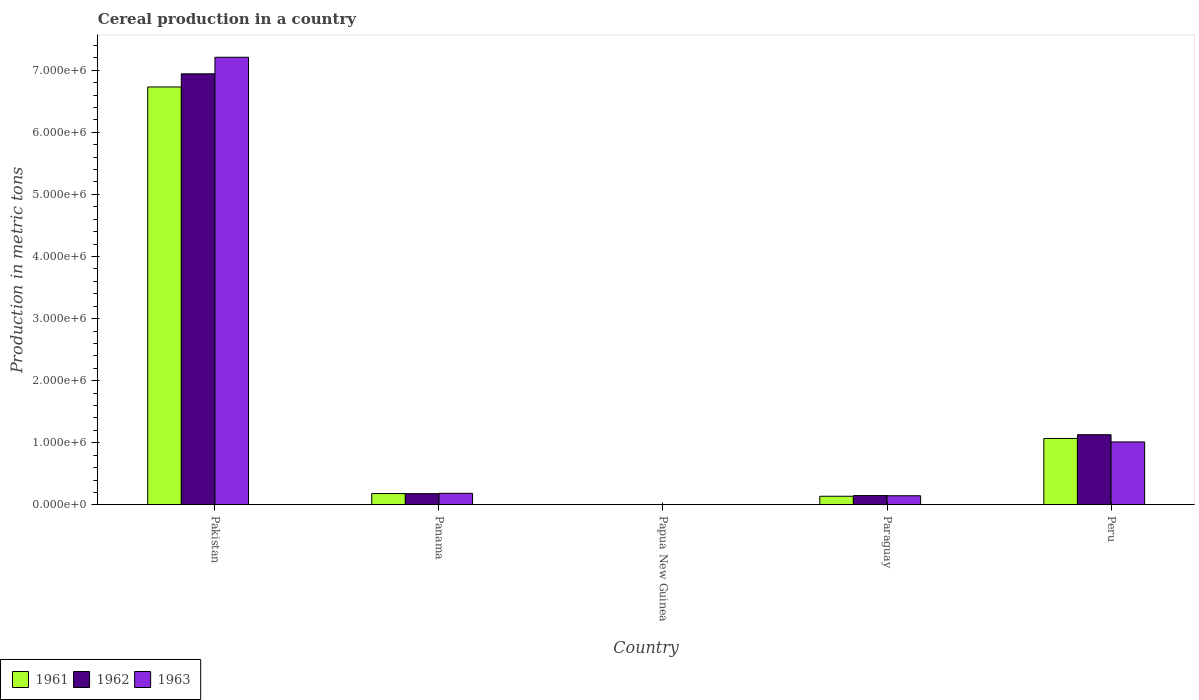How many different coloured bars are there?
Provide a short and direct response. 3. Are the number of bars on each tick of the X-axis equal?
Your answer should be compact. Yes. How many bars are there on the 5th tick from the right?
Give a very brief answer. 3. What is the total cereal production in 1962 in Papua New Guinea?
Ensure brevity in your answer.  1891. Across all countries, what is the maximum total cereal production in 1962?
Give a very brief answer. 6.94e+06. Across all countries, what is the minimum total cereal production in 1963?
Provide a short and direct response. 1871. In which country was the total cereal production in 1962 maximum?
Your answer should be compact. Pakistan. In which country was the total cereal production in 1961 minimum?
Keep it short and to the point. Papua New Guinea. What is the total total cereal production in 1962 in the graph?
Your response must be concise. 8.41e+06. What is the difference between the total cereal production in 1962 in Papua New Guinea and that in Paraguay?
Give a very brief answer. -1.49e+05. What is the difference between the total cereal production in 1961 in Pakistan and the total cereal production in 1962 in Panama?
Provide a short and direct response. 6.55e+06. What is the average total cereal production in 1961 per country?
Your answer should be compact. 1.62e+06. What is the difference between the total cereal production of/in 1962 and total cereal production of/in 1961 in Papua New Guinea?
Your response must be concise. 41. What is the ratio of the total cereal production in 1963 in Panama to that in Papua New Guinea?
Make the answer very short. 99.94. Is the total cereal production in 1962 in Papua New Guinea less than that in Peru?
Your response must be concise. Yes. What is the difference between the highest and the second highest total cereal production in 1961?
Provide a short and direct response. 6.55e+06. What is the difference between the highest and the lowest total cereal production in 1961?
Give a very brief answer. 6.73e+06. In how many countries, is the total cereal production in 1962 greater than the average total cereal production in 1962 taken over all countries?
Your answer should be very brief. 1. How many bars are there?
Keep it short and to the point. 15. What is the difference between two consecutive major ticks on the Y-axis?
Your response must be concise. 1.00e+06. Are the values on the major ticks of Y-axis written in scientific E-notation?
Your answer should be compact. Yes. Does the graph contain any zero values?
Offer a very short reply. No. How many legend labels are there?
Ensure brevity in your answer.  3. How are the legend labels stacked?
Provide a short and direct response. Horizontal. What is the title of the graph?
Make the answer very short. Cereal production in a country. Does "1986" appear as one of the legend labels in the graph?
Provide a short and direct response. No. What is the label or title of the X-axis?
Offer a terse response. Country. What is the label or title of the Y-axis?
Give a very brief answer. Production in metric tons. What is the Production in metric tons of 1961 in Pakistan?
Your response must be concise. 6.73e+06. What is the Production in metric tons of 1962 in Pakistan?
Give a very brief answer. 6.94e+06. What is the Production in metric tons in 1963 in Pakistan?
Offer a very short reply. 7.21e+06. What is the Production in metric tons of 1961 in Panama?
Offer a terse response. 1.83e+05. What is the Production in metric tons in 1962 in Panama?
Give a very brief answer. 1.82e+05. What is the Production in metric tons of 1963 in Panama?
Offer a very short reply. 1.87e+05. What is the Production in metric tons of 1961 in Papua New Guinea?
Your answer should be compact. 1850. What is the Production in metric tons in 1962 in Papua New Guinea?
Ensure brevity in your answer.  1891. What is the Production in metric tons in 1963 in Papua New Guinea?
Make the answer very short. 1871. What is the Production in metric tons of 1961 in Paraguay?
Offer a very short reply. 1.40e+05. What is the Production in metric tons of 1962 in Paraguay?
Your response must be concise. 1.51e+05. What is the Production in metric tons in 1963 in Paraguay?
Ensure brevity in your answer.  1.48e+05. What is the Production in metric tons in 1961 in Peru?
Provide a succinct answer. 1.07e+06. What is the Production in metric tons in 1962 in Peru?
Your answer should be compact. 1.13e+06. What is the Production in metric tons of 1963 in Peru?
Offer a very short reply. 1.01e+06. Across all countries, what is the maximum Production in metric tons of 1961?
Keep it short and to the point. 6.73e+06. Across all countries, what is the maximum Production in metric tons in 1962?
Provide a succinct answer. 6.94e+06. Across all countries, what is the maximum Production in metric tons in 1963?
Your response must be concise. 7.21e+06. Across all countries, what is the minimum Production in metric tons in 1961?
Give a very brief answer. 1850. Across all countries, what is the minimum Production in metric tons in 1962?
Your answer should be very brief. 1891. Across all countries, what is the minimum Production in metric tons of 1963?
Offer a very short reply. 1871. What is the total Production in metric tons of 1961 in the graph?
Make the answer very short. 8.12e+06. What is the total Production in metric tons of 1962 in the graph?
Your response must be concise. 8.41e+06. What is the total Production in metric tons of 1963 in the graph?
Your answer should be compact. 8.56e+06. What is the difference between the Production in metric tons in 1961 in Pakistan and that in Panama?
Make the answer very short. 6.55e+06. What is the difference between the Production in metric tons in 1962 in Pakistan and that in Panama?
Your response must be concise. 6.76e+06. What is the difference between the Production in metric tons of 1963 in Pakistan and that in Panama?
Your response must be concise. 7.02e+06. What is the difference between the Production in metric tons in 1961 in Pakistan and that in Papua New Guinea?
Your answer should be very brief. 6.73e+06. What is the difference between the Production in metric tons of 1962 in Pakistan and that in Papua New Guinea?
Offer a very short reply. 6.94e+06. What is the difference between the Production in metric tons of 1963 in Pakistan and that in Papua New Guinea?
Your response must be concise. 7.21e+06. What is the difference between the Production in metric tons in 1961 in Pakistan and that in Paraguay?
Provide a succinct answer. 6.59e+06. What is the difference between the Production in metric tons in 1962 in Pakistan and that in Paraguay?
Your answer should be compact. 6.79e+06. What is the difference between the Production in metric tons in 1963 in Pakistan and that in Paraguay?
Your answer should be very brief. 7.06e+06. What is the difference between the Production in metric tons in 1961 in Pakistan and that in Peru?
Your answer should be very brief. 5.66e+06. What is the difference between the Production in metric tons of 1962 in Pakistan and that in Peru?
Provide a short and direct response. 5.81e+06. What is the difference between the Production in metric tons of 1963 in Pakistan and that in Peru?
Your answer should be compact. 6.19e+06. What is the difference between the Production in metric tons of 1961 in Panama and that in Papua New Guinea?
Provide a succinct answer. 1.81e+05. What is the difference between the Production in metric tons of 1962 in Panama and that in Papua New Guinea?
Your answer should be compact. 1.80e+05. What is the difference between the Production in metric tons in 1963 in Panama and that in Papua New Guinea?
Make the answer very short. 1.85e+05. What is the difference between the Production in metric tons in 1961 in Panama and that in Paraguay?
Keep it short and to the point. 4.32e+04. What is the difference between the Production in metric tons in 1962 in Panama and that in Paraguay?
Make the answer very short. 3.08e+04. What is the difference between the Production in metric tons of 1963 in Panama and that in Paraguay?
Offer a terse response. 3.92e+04. What is the difference between the Production in metric tons in 1961 in Panama and that in Peru?
Your response must be concise. -8.87e+05. What is the difference between the Production in metric tons in 1962 in Panama and that in Peru?
Provide a succinct answer. -9.49e+05. What is the difference between the Production in metric tons in 1963 in Panama and that in Peru?
Make the answer very short. -8.27e+05. What is the difference between the Production in metric tons of 1961 in Papua New Guinea and that in Paraguay?
Make the answer very short. -1.38e+05. What is the difference between the Production in metric tons of 1962 in Papua New Guinea and that in Paraguay?
Offer a very short reply. -1.49e+05. What is the difference between the Production in metric tons of 1963 in Papua New Guinea and that in Paraguay?
Your answer should be very brief. -1.46e+05. What is the difference between the Production in metric tons in 1961 in Papua New Guinea and that in Peru?
Make the answer very short. -1.07e+06. What is the difference between the Production in metric tons of 1962 in Papua New Guinea and that in Peru?
Give a very brief answer. -1.13e+06. What is the difference between the Production in metric tons in 1963 in Papua New Guinea and that in Peru?
Ensure brevity in your answer.  -1.01e+06. What is the difference between the Production in metric tons of 1961 in Paraguay and that in Peru?
Give a very brief answer. -9.30e+05. What is the difference between the Production in metric tons of 1962 in Paraguay and that in Peru?
Your answer should be compact. -9.80e+05. What is the difference between the Production in metric tons of 1963 in Paraguay and that in Peru?
Offer a very short reply. -8.67e+05. What is the difference between the Production in metric tons in 1961 in Pakistan and the Production in metric tons in 1962 in Panama?
Your answer should be compact. 6.55e+06. What is the difference between the Production in metric tons of 1961 in Pakistan and the Production in metric tons of 1963 in Panama?
Provide a succinct answer. 6.54e+06. What is the difference between the Production in metric tons of 1962 in Pakistan and the Production in metric tons of 1963 in Panama?
Offer a very short reply. 6.75e+06. What is the difference between the Production in metric tons in 1961 in Pakistan and the Production in metric tons in 1962 in Papua New Guinea?
Provide a succinct answer. 6.73e+06. What is the difference between the Production in metric tons of 1961 in Pakistan and the Production in metric tons of 1963 in Papua New Guinea?
Provide a succinct answer. 6.73e+06. What is the difference between the Production in metric tons of 1962 in Pakistan and the Production in metric tons of 1963 in Papua New Guinea?
Provide a succinct answer. 6.94e+06. What is the difference between the Production in metric tons in 1961 in Pakistan and the Production in metric tons in 1962 in Paraguay?
Your response must be concise. 6.58e+06. What is the difference between the Production in metric tons of 1961 in Pakistan and the Production in metric tons of 1963 in Paraguay?
Offer a very short reply. 6.58e+06. What is the difference between the Production in metric tons of 1962 in Pakistan and the Production in metric tons of 1963 in Paraguay?
Offer a terse response. 6.79e+06. What is the difference between the Production in metric tons in 1961 in Pakistan and the Production in metric tons in 1962 in Peru?
Provide a succinct answer. 5.60e+06. What is the difference between the Production in metric tons of 1961 in Pakistan and the Production in metric tons of 1963 in Peru?
Your answer should be compact. 5.72e+06. What is the difference between the Production in metric tons of 1962 in Pakistan and the Production in metric tons of 1963 in Peru?
Give a very brief answer. 5.93e+06. What is the difference between the Production in metric tons of 1961 in Panama and the Production in metric tons of 1962 in Papua New Guinea?
Offer a terse response. 1.81e+05. What is the difference between the Production in metric tons in 1961 in Panama and the Production in metric tons in 1963 in Papua New Guinea?
Give a very brief answer. 1.81e+05. What is the difference between the Production in metric tons of 1962 in Panama and the Production in metric tons of 1963 in Papua New Guinea?
Give a very brief answer. 1.80e+05. What is the difference between the Production in metric tons of 1961 in Panama and the Production in metric tons of 1962 in Paraguay?
Offer a very short reply. 3.21e+04. What is the difference between the Production in metric tons in 1961 in Panama and the Production in metric tons in 1963 in Paraguay?
Make the answer very short. 3.51e+04. What is the difference between the Production in metric tons in 1962 in Panama and the Production in metric tons in 1963 in Paraguay?
Offer a terse response. 3.38e+04. What is the difference between the Production in metric tons in 1961 in Panama and the Production in metric tons in 1962 in Peru?
Provide a short and direct response. -9.48e+05. What is the difference between the Production in metric tons of 1961 in Panama and the Production in metric tons of 1963 in Peru?
Keep it short and to the point. -8.32e+05. What is the difference between the Production in metric tons of 1962 in Panama and the Production in metric tons of 1963 in Peru?
Keep it short and to the point. -8.33e+05. What is the difference between the Production in metric tons of 1961 in Papua New Guinea and the Production in metric tons of 1962 in Paraguay?
Keep it short and to the point. -1.49e+05. What is the difference between the Production in metric tons in 1961 in Papua New Guinea and the Production in metric tons in 1963 in Paraguay?
Ensure brevity in your answer.  -1.46e+05. What is the difference between the Production in metric tons in 1962 in Papua New Guinea and the Production in metric tons in 1963 in Paraguay?
Your answer should be compact. -1.46e+05. What is the difference between the Production in metric tons of 1961 in Papua New Guinea and the Production in metric tons of 1962 in Peru?
Offer a terse response. -1.13e+06. What is the difference between the Production in metric tons of 1961 in Papua New Guinea and the Production in metric tons of 1963 in Peru?
Provide a succinct answer. -1.01e+06. What is the difference between the Production in metric tons in 1962 in Papua New Guinea and the Production in metric tons in 1963 in Peru?
Keep it short and to the point. -1.01e+06. What is the difference between the Production in metric tons in 1961 in Paraguay and the Production in metric tons in 1962 in Peru?
Give a very brief answer. -9.91e+05. What is the difference between the Production in metric tons of 1961 in Paraguay and the Production in metric tons of 1963 in Peru?
Provide a short and direct response. -8.75e+05. What is the difference between the Production in metric tons in 1962 in Paraguay and the Production in metric tons in 1963 in Peru?
Make the answer very short. -8.64e+05. What is the average Production in metric tons in 1961 per country?
Your response must be concise. 1.62e+06. What is the average Production in metric tons of 1962 per country?
Your answer should be very brief. 1.68e+06. What is the average Production in metric tons of 1963 per country?
Your answer should be compact. 1.71e+06. What is the difference between the Production in metric tons in 1961 and Production in metric tons in 1962 in Pakistan?
Provide a short and direct response. -2.12e+05. What is the difference between the Production in metric tons of 1961 and Production in metric tons of 1963 in Pakistan?
Provide a short and direct response. -4.79e+05. What is the difference between the Production in metric tons in 1962 and Production in metric tons in 1963 in Pakistan?
Offer a very short reply. -2.67e+05. What is the difference between the Production in metric tons in 1961 and Production in metric tons in 1962 in Panama?
Provide a succinct answer. 1297. What is the difference between the Production in metric tons of 1961 and Production in metric tons of 1963 in Panama?
Provide a succinct answer. -4110. What is the difference between the Production in metric tons in 1962 and Production in metric tons in 1963 in Panama?
Ensure brevity in your answer.  -5407. What is the difference between the Production in metric tons in 1961 and Production in metric tons in 1962 in Papua New Guinea?
Your answer should be compact. -41. What is the difference between the Production in metric tons in 1961 and Production in metric tons in 1963 in Papua New Guinea?
Provide a short and direct response. -21. What is the difference between the Production in metric tons of 1961 and Production in metric tons of 1962 in Paraguay?
Your answer should be very brief. -1.11e+04. What is the difference between the Production in metric tons of 1961 and Production in metric tons of 1963 in Paraguay?
Offer a terse response. -8100. What is the difference between the Production in metric tons of 1962 and Production in metric tons of 1963 in Paraguay?
Make the answer very short. 3000. What is the difference between the Production in metric tons of 1961 and Production in metric tons of 1962 in Peru?
Your answer should be compact. -6.05e+04. What is the difference between the Production in metric tons in 1961 and Production in metric tons in 1963 in Peru?
Give a very brief answer. 5.57e+04. What is the difference between the Production in metric tons of 1962 and Production in metric tons of 1963 in Peru?
Keep it short and to the point. 1.16e+05. What is the ratio of the Production in metric tons in 1961 in Pakistan to that in Panama?
Provide a succinct answer. 36.8. What is the ratio of the Production in metric tons in 1962 in Pakistan to that in Panama?
Provide a succinct answer. 38.23. What is the ratio of the Production in metric tons of 1963 in Pakistan to that in Panama?
Keep it short and to the point. 38.55. What is the ratio of the Production in metric tons in 1961 in Pakistan to that in Papua New Guinea?
Ensure brevity in your answer.  3637.66. What is the ratio of the Production in metric tons in 1962 in Pakistan to that in Papua New Guinea?
Your response must be concise. 3670.86. What is the ratio of the Production in metric tons in 1963 in Pakistan to that in Papua New Guinea?
Your answer should be very brief. 3852.65. What is the ratio of the Production in metric tons of 1961 in Pakistan to that in Paraguay?
Ensure brevity in your answer.  48.17. What is the ratio of the Production in metric tons in 1962 in Pakistan to that in Paraguay?
Your answer should be compact. 46.03. What is the ratio of the Production in metric tons of 1963 in Pakistan to that in Paraguay?
Your answer should be compact. 48.77. What is the ratio of the Production in metric tons in 1961 in Pakistan to that in Peru?
Offer a terse response. 6.29. What is the ratio of the Production in metric tons in 1962 in Pakistan to that in Peru?
Provide a short and direct response. 6.14. What is the ratio of the Production in metric tons in 1963 in Pakistan to that in Peru?
Make the answer very short. 7.11. What is the ratio of the Production in metric tons of 1961 in Panama to that in Papua New Guinea?
Your answer should be compact. 98.86. What is the ratio of the Production in metric tons of 1962 in Panama to that in Papua New Guinea?
Make the answer very short. 96.03. What is the ratio of the Production in metric tons of 1963 in Panama to that in Papua New Guinea?
Your answer should be compact. 99.94. What is the ratio of the Production in metric tons in 1961 in Panama to that in Paraguay?
Offer a terse response. 1.31. What is the ratio of the Production in metric tons of 1962 in Panama to that in Paraguay?
Offer a very short reply. 1.2. What is the ratio of the Production in metric tons of 1963 in Panama to that in Paraguay?
Ensure brevity in your answer.  1.27. What is the ratio of the Production in metric tons in 1961 in Panama to that in Peru?
Provide a succinct answer. 0.17. What is the ratio of the Production in metric tons of 1962 in Panama to that in Peru?
Keep it short and to the point. 0.16. What is the ratio of the Production in metric tons in 1963 in Panama to that in Peru?
Your response must be concise. 0.18. What is the ratio of the Production in metric tons in 1961 in Papua New Guinea to that in Paraguay?
Offer a very short reply. 0.01. What is the ratio of the Production in metric tons in 1962 in Papua New Guinea to that in Paraguay?
Keep it short and to the point. 0.01. What is the ratio of the Production in metric tons of 1963 in Papua New Guinea to that in Paraguay?
Your response must be concise. 0.01. What is the ratio of the Production in metric tons of 1961 in Papua New Guinea to that in Peru?
Give a very brief answer. 0. What is the ratio of the Production in metric tons of 1962 in Papua New Guinea to that in Peru?
Keep it short and to the point. 0. What is the ratio of the Production in metric tons in 1963 in Papua New Guinea to that in Peru?
Your answer should be very brief. 0. What is the ratio of the Production in metric tons of 1961 in Paraguay to that in Peru?
Provide a succinct answer. 0.13. What is the ratio of the Production in metric tons in 1962 in Paraguay to that in Peru?
Ensure brevity in your answer.  0.13. What is the ratio of the Production in metric tons in 1963 in Paraguay to that in Peru?
Provide a short and direct response. 0.15. What is the difference between the highest and the second highest Production in metric tons in 1961?
Keep it short and to the point. 5.66e+06. What is the difference between the highest and the second highest Production in metric tons of 1962?
Offer a terse response. 5.81e+06. What is the difference between the highest and the second highest Production in metric tons of 1963?
Your answer should be compact. 6.19e+06. What is the difference between the highest and the lowest Production in metric tons in 1961?
Offer a very short reply. 6.73e+06. What is the difference between the highest and the lowest Production in metric tons in 1962?
Give a very brief answer. 6.94e+06. What is the difference between the highest and the lowest Production in metric tons of 1963?
Provide a succinct answer. 7.21e+06. 